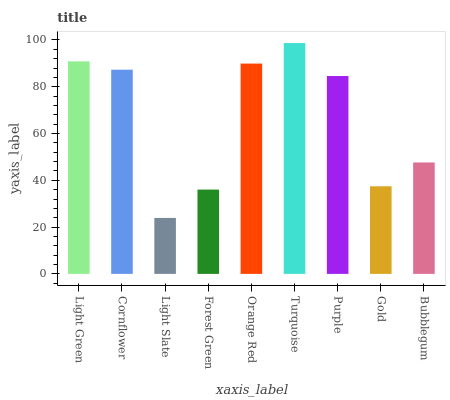Is Light Slate the minimum?
Answer yes or no. Yes. Is Turquoise the maximum?
Answer yes or no. Yes. Is Cornflower the minimum?
Answer yes or no. No. Is Cornflower the maximum?
Answer yes or no. No. Is Light Green greater than Cornflower?
Answer yes or no. Yes. Is Cornflower less than Light Green?
Answer yes or no. Yes. Is Cornflower greater than Light Green?
Answer yes or no. No. Is Light Green less than Cornflower?
Answer yes or no. No. Is Purple the high median?
Answer yes or no. Yes. Is Purple the low median?
Answer yes or no. Yes. Is Light Slate the high median?
Answer yes or no. No. Is Cornflower the low median?
Answer yes or no. No. 